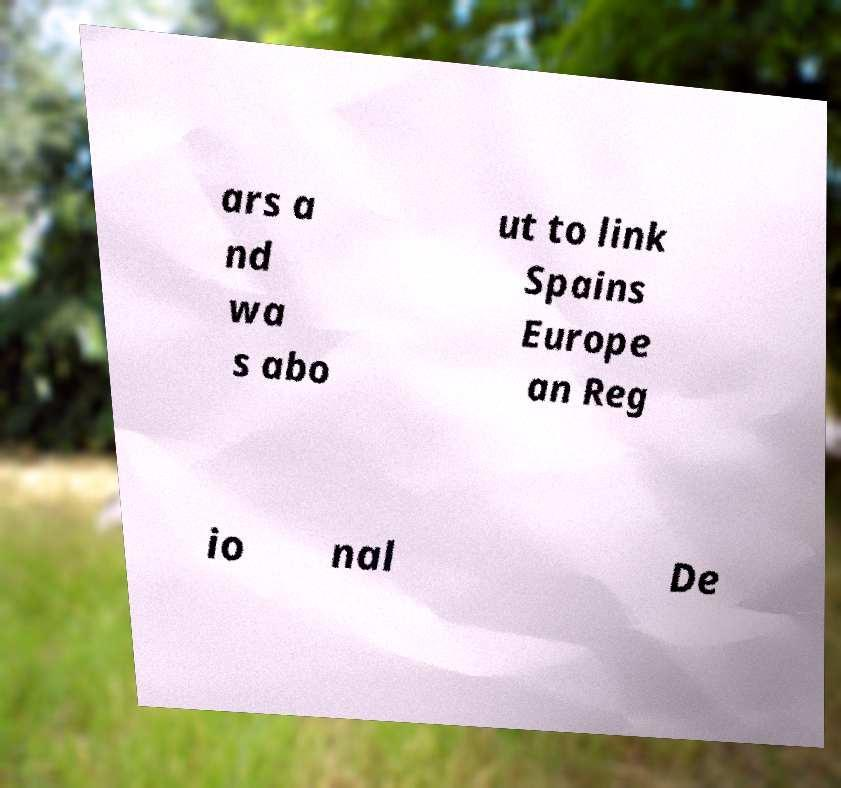Can you accurately transcribe the text from the provided image for me? ars a nd wa s abo ut to link Spains Europe an Reg io nal De 